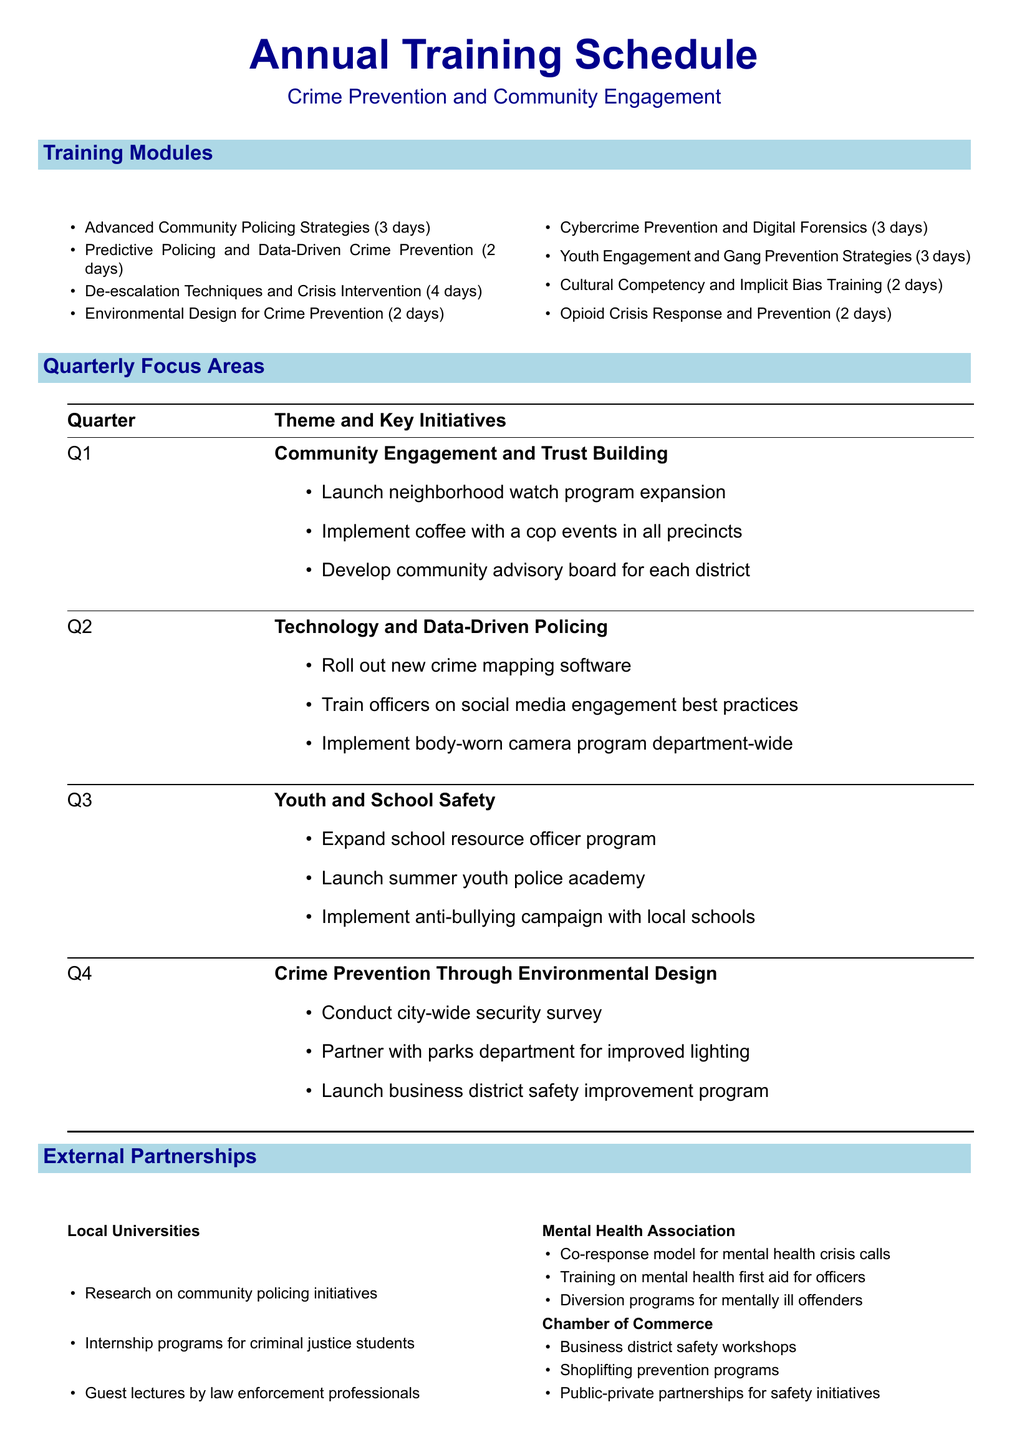What is the duration of the "Predictive Policing and Data-Driven Crime Prevention" module? The duration is specified in the document for each training module.
Answer: 2 days Who is the instructor for "De-escalation Techniques and Crisis Intervention"? The document lists the instructor for each training module.
Answer: Sgt. Jennifer Lewis, Crisis Intervention Team Coordinator, Seattle Police Department What is the theme for Q3? The document outlines themes for each quarter, including the focus areas.
Answer: Youth and School Safety How many training modules are listed in the schedule? The total count of training modules is provided in the training modules section.
Answer: 8 Which external partner focuses on mental health training for officers? The document specifies the areas of collaboration for each external partner.
Answer: Mental Health Association What is one initiative under Q1? The document provides key initiatives for each quarterly theme.
Answer: Launch neighborhood watch program expansion Who teaches the "Cultural Competency and Implicit Bias Training"? The instructor is associated with each training module in the document.
Answer: Dr. Jamal Washington, Diversity and Inclusion Consultant, Police Executive Research Forum What is the total duration of the "Opioid Crisis Response and Prevention" module? The document states the duration for all training modules.
Answer: 2 days What is the focus of Q2 initiatives? The document identifies the theme for each quarter along with key initiatives.
Answer: Technology and Data-Driven Policing 